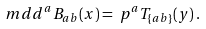Convert formula to latex. <formula><loc_0><loc_0><loc_500><loc_500>\ m d d ^ { a } B _ { a b } ( x ) & = \ p ^ { a } T _ { \{ a b \} } ( y ) \, .</formula> 